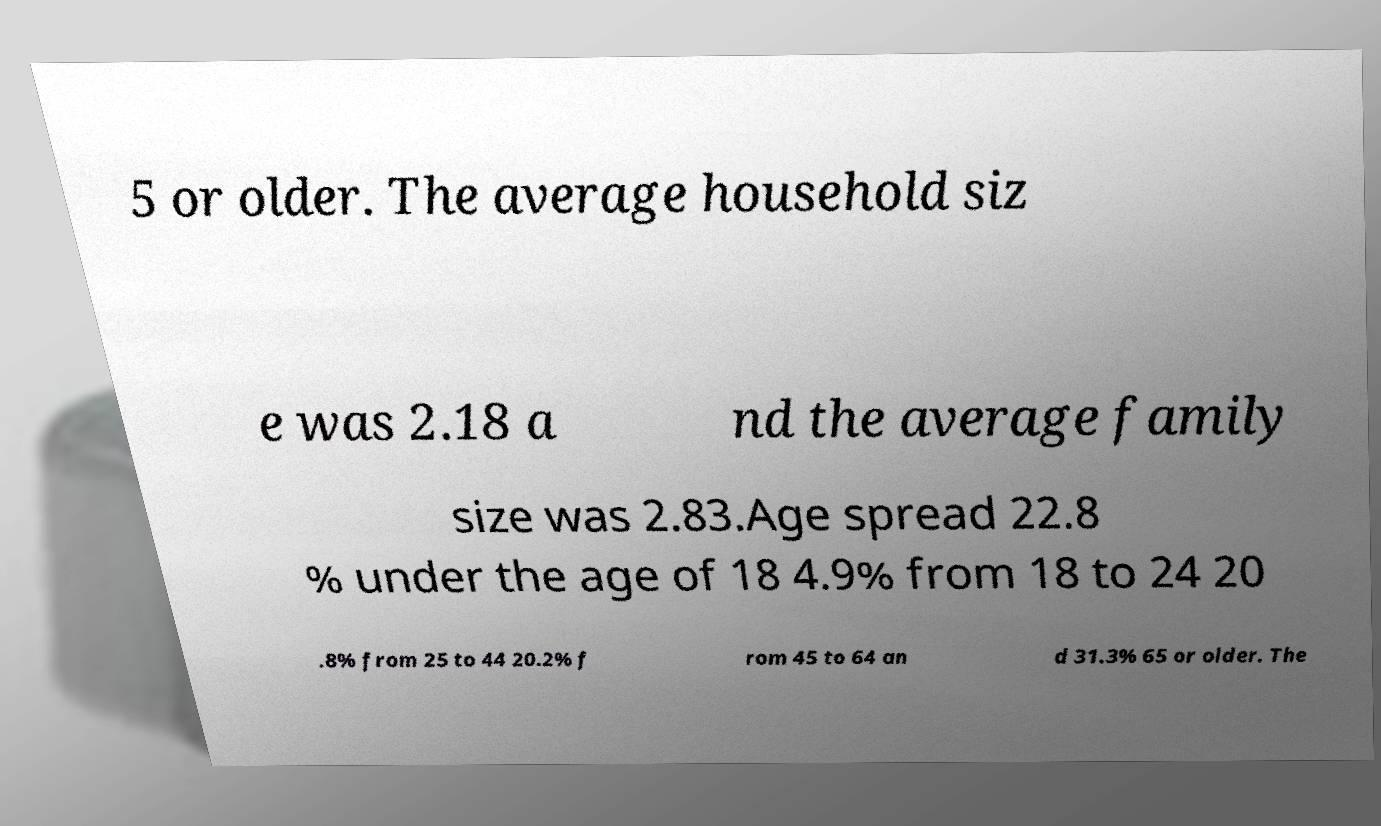There's text embedded in this image that I need extracted. Can you transcribe it verbatim? 5 or older. The average household siz e was 2.18 a nd the average family size was 2.83.Age spread 22.8 % under the age of 18 4.9% from 18 to 24 20 .8% from 25 to 44 20.2% f rom 45 to 64 an d 31.3% 65 or older. The 